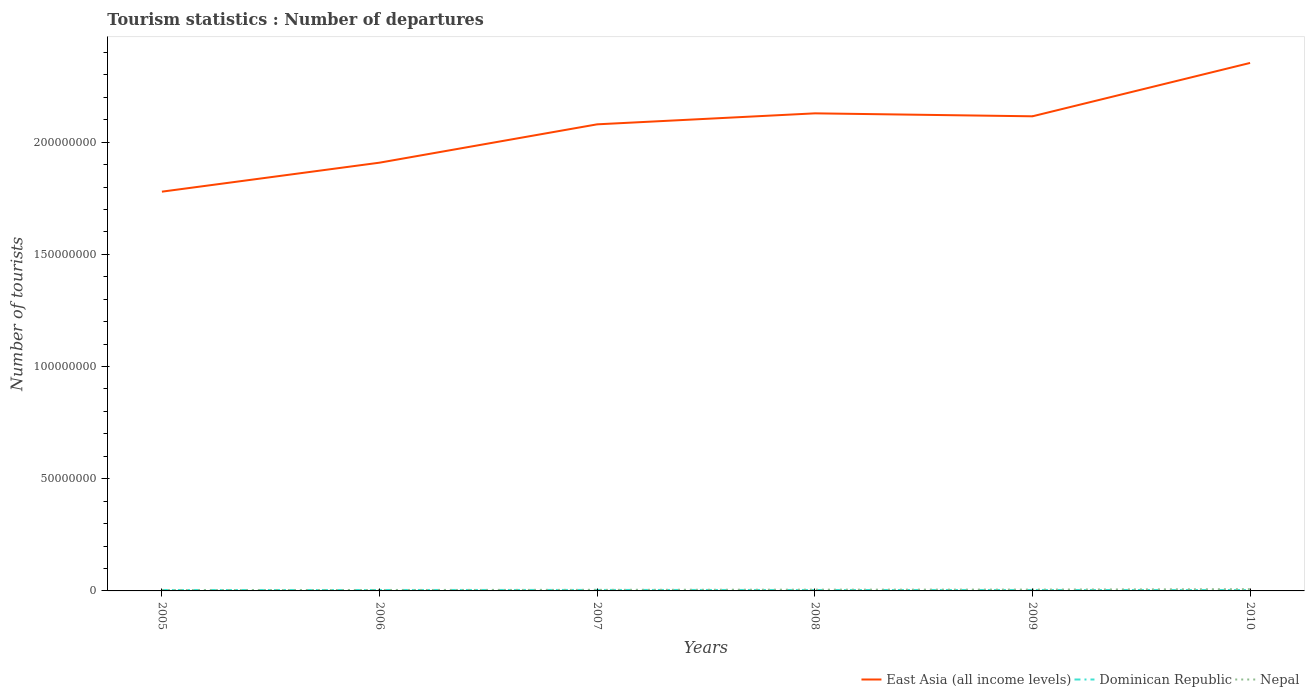Across all years, what is the maximum number of tourist departures in Nepal?
Keep it short and to the point. 3.73e+05. What is the total number of tourist departures in East Asia (all income levels) in the graph?
Keep it short and to the point. -2.38e+07. What is the difference between the highest and the second highest number of tourist departures in Dominican Republic?
Provide a short and direct response. 4.20e+04. Is the number of tourist departures in East Asia (all income levels) strictly greater than the number of tourist departures in Nepal over the years?
Provide a succinct answer. No. How many years are there in the graph?
Ensure brevity in your answer.  6. What is the difference between two consecutive major ticks on the Y-axis?
Make the answer very short. 5.00e+07. Does the graph contain any zero values?
Offer a very short reply. No. Does the graph contain grids?
Offer a very short reply. No. Where does the legend appear in the graph?
Provide a short and direct response. Bottom right. How many legend labels are there?
Your response must be concise. 3. How are the legend labels stacked?
Provide a succinct answer. Horizontal. What is the title of the graph?
Your answer should be very brief. Tourism statistics : Number of departures. Does "High income: nonOECD" appear as one of the legend labels in the graph?
Ensure brevity in your answer.  No. What is the label or title of the X-axis?
Keep it short and to the point. Years. What is the label or title of the Y-axis?
Keep it short and to the point. Number of tourists. What is the Number of tourists of East Asia (all income levels) in 2005?
Your answer should be very brief. 1.78e+08. What is the Number of tourists of Dominican Republic in 2005?
Provide a short and direct response. 4.19e+05. What is the Number of tourists in Nepal in 2005?
Your answer should be very brief. 3.73e+05. What is the Number of tourists of East Asia (all income levels) in 2006?
Make the answer very short. 1.91e+08. What is the Number of tourists in Nepal in 2006?
Provide a short and direct response. 4.15e+05. What is the Number of tourists in East Asia (all income levels) in 2007?
Give a very brief answer. 2.08e+08. What is the Number of tourists of Dominican Republic in 2007?
Ensure brevity in your answer.  4.43e+05. What is the Number of tourists of Nepal in 2007?
Provide a short and direct response. 4.69e+05. What is the Number of tourists of East Asia (all income levels) in 2008?
Offer a terse response. 2.13e+08. What is the Number of tourists in Dominican Republic in 2008?
Give a very brief answer. 4.13e+05. What is the Number of tourists of Nepal in 2008?
Your answer should be compact. 5.61e+05. What is the Number of tourists in East Asia (all income levels) in 2009?
Your response must be concise. 2.12e+08. What is the Number of tourists of Dominican Republic in 2009?
Provide a short and direct response. 4.15e+05. What is the Number of tourists in Nepal in 2009?
Provide a short and direct response. 5.89e+05. What is the Number of tourists in East Asia (all income levels) in 2010?
Provide a succinct answer. 2.35e+08. What is the Number of tourists in Dominican Republic in 2010?
Provide a short and direct response. 4.01e+05. What is the Number of tourists in Nepal in 2010?
Your answer should be very brief. 7.65e+05. Across all years, what is the maximum Number of tourists in East Asia (all income levels)?
Give a very brief answer. 2.35e+08. Across all years, what is the maximum Number of tourists in Dominican Republic?
Your response must be concise. 4.43e+05. Across all years, what is the maximum Number of tourists of Nepal?
Provide a succinct answer. 7.65e+05. Across all years, what is the minimum Number of tourists in East Asia (all income levels)?
Offer a very short reply. 1.78e+08. Across all years, what is the minimum Number of tourists in Dominican Republic?
Your response must be concise. 4.01e+05. Across all years, what is the minimum Number of tourists in Nepal?
Make the answer very short. 3.73e+05. What is the total Number of tourists of East Asia (all income levels) in the graph?
Provide a succinct answer. 1.24e+09. What is the total Number of tourists of Dominican Republic in the graph?
Give a very brief answer. 2.51e+06. What is the total Number of tourists in Nepal in the graph?
Offer a very short reply. 3.17e+06. What is the difference between the Number of tourists in East Asia (all income levels) in 2005 and that in 2006?
Give a very brief answer. -1.29e+07. What is the difference between the Number of tourists of Dominican Republic in 2005 and that in 2006?
Your answer should be compact. -1000. What is the difference between the Number of tourists in Nepal in 2005 and that in 2006?
Offer a terse response. -4.20e+04. What is the difference between the Number of tourists of East Asia (all income levels) in 2005 and that in 2007?
Your response must be concise. -3.00e+07. What is the difference between the Number of tourists in Dominican Republic in 2005 and that in 2007?
Your answer should be compact. -2.40e+04. What is the difference between the Number of tourists in Nepal in 2005 and that in 2007?
Offer a very short reply. -9.60e+04. What is the difference between the Number of tourists of East Asia (all income levels) in 2005 and that in 2008?
Offer a terse response. -3.49e+07. What is the difference between the Number of tourists of Dominican Republic in 2005 and that in 2008?
Your answer should be compact. 6000. What is the difference between the Number of tourists in Nepal in 2005 and that in 2008?
Your answer should be very brief. -1.88e+05. What is the difference between the Number of tourists of East Asia (all income levels) in 2005 and that in 2009?
Offer a terse response. -3.36e+07. What is the difference between the Number of tourists in Dominican Republic in 2005 and that in 2009?
Make the answer very short. 4000. What is the difference between the Number of tourists in Nepal in 2005 and that in 2009?
Offer a terse response. -2.16e+05. What is the difference between the Number of tourists in East Asia (all income levels) in 2005 and that in 2010?
Your answer should be compact. -5.74e+07. What is the difference between the Number of tourists in Dominican Republic in 2005 and that in 2010?
Give a very brief answer. 1.80e+04. What is the difference between the Number of tourists in Nepal in 2005 and that in 2010?
Ensure brevity in your answer.  -3.92e+05. What is the difference between the Number of tourists in East Asia (all income levels) in 2006 and that in 2007?
Offer a very short reply. -1.71e+07. What is the difference between the Number of tourists of Dominican Republic in 2006 and that in 2007?
Provide a short and direct response. -2.30e+04. What is the difference between the Number of tourists in Nepal in 2006 and that in 2007?
Provide a short and direct response. -5.40e+04. What is the difference between the Number of tourists of East Asia (all income levels) in 2006 and that in 2008?
Provide a short and direct response. -2.20e+07. What is the difference between the Number of tourists of Dominican Republic in 2006 and that in 2008?
Your answer should be compact. 7000. What is the difference between the Number of tourists of Nepal in 2006 and that in 2008?
Keep it short and to the point. -1.46e+05. What is the difference between the Number of tourists of East Asia (all income levels) in 2006 and that in 2009?
Keep it short and to the point. -2.07e+07. What is the difference between the Number of tourists in Nepal in 2006 and that in 2009?
Give a very brief answer. -1.74e+05. What is the difference between the Number of tourists in East Asia (all income levels) in 2006 and that in 2010?
Offer a very short reply. -4.45e+07. What is the difference between the Number of tourists in Dominican Republic in 2006 and that in 2010?
Give a very brief answer. 1.90e+04. What is the difference between the Number of tourists of Nepal in 2006 and that in 2010?
Offer a terse response. -3.50e+05. What is the difference between the Number of tourists in East Asia (all income levels) in 2007 and that in 2008?
Ensure brevity in your answer.  -4.89e+06. What is the difference between the Number of tourists of Dominican Republic in 2007 and that in 2008?
Make the answer very short. 3.00e+04. What is the difference between the Number of tourists in Nepal in 2007 and that in 2008?
Provide a succinct answer. -9.20e+04. What is the difference between the Number of tourists in East Asia (all income levels) in 2007 and that in 2009?
Ensure brevity in your answer.  -3.58e+06. What is the difference between the Number of tourists of Dominican Republic in 2007 and that in 2009?
Offer a very short reply. 2.80e+04. What is the difference between the Number of tourists in East Asia (all income levels) in 2007 and that in 2010?
Give a very brief answer. -2.74e+07. What is the difference between the Number of tourists in Dominican Republic in 2007 and that in 2010?
Keep it short and to the point. 4.20e+04. What is the difference between the Number of tourists in Nepal in 2007 and that in 2010?
Your answer should be very brief. -2.96e+05. What is the difference between the Number of tourists in East Asia (all income levels) in 2008 and that in 2009?
Provide a short and direct response. 1.31e+06. What is the difference between the Number of tourists of Dominican Republic in 2008 and that in 2009?
Offer a terse response. -2000. What is the difference between the Number of tourists in Nepal in 2008 and that in 2009?
Your response must be concise. -2.80e+04. What is the difference between the Number of tourists in East Asia (all income levels) in 2008 and that in 2010?
Ensure brevity in your answer.  -2.25e+07. What is the difference between the Number of tourists in Dominican Republic in 2008 and that in 2010?
Keep it short and to the point. 1.20e+04. What is the difference between the Number of tourists of Nepal in 2008 and that in 2010?
Give a very brief answer. -2.04e+05. What is the difference between the Number of tourists of East Asia (all income levels) in 2009 and that in 2010?
Your answer should be compact. -2.38e+07. What is the difference between the Number of tourists of Dominican Republic in 2009 and that in 2010?
Provide a short and direct response. 1.40e+04. What is the difference between the Number of tourists of Nepal in 2009 and that in 2010?
Offer a very short reply. -1.76e+05. What is the difference between the Number of tourists of East Asia (all income levels) in 2005 and the Number of tourists of Dominican Republic in 2006?
Ensure brevity in your answer.  1.78e+08. What is the difference between the Number of tourists of East Asia (all income levels) in 2005 and the Number of tourists of Nepal in 2006?
Offer a very short reply. 1.78e+08. What is the difference between the Number of tourists of Dominican Republic in 2005 and the Number of tourists of Nepal in 2006?
Give a very brief answer. 4000. What is the difference between the Number of tourists of East Asia (all income levels) in 2005 and the Number of tourists of Dominican Republic in 2007?
Ensure brevity in your answer.  1.77e+08. What is the difference between the Number of tourists in East Asia (all income levels) in 2005 and the Number of tourists in Nepal in 2007?
Provide a short and direct response. 1.77e+08. What is the difference between the Number of tourists in Dominican Republic in 2005 and the Number of tourists in Nepal in 2007?
Your answer should be compact. -5.00e+04. What is the difference between the Number of tourists in East Asia (all income levels) in 2005 and the Number of tourists in Dominican Republic in 2008?
Your answer should be very brief. 1.78e+08. What is the difference between the Number of tourists in East Asia (all income levels) in 2005 and the Number of tourists in Nepal in 2008?
Your response must be concise. 1.77e+08. What is the difference between the Number of tourists in Dominican Republic in 2005 and the Number of tourists in Nepal in 2008?
Your answer should be compact. -1.42e+05. What is the difference between the Number of tourists in East Asia (all income levels) in 2005 and the Number of tourists in Dominican Republic in 2009?
Ensure brevity in your answer.  1.78e+08. What is the difference between the Number of tourists of East Asia (all income levels) in 2005 and the Number of tourists of Nepal in 2009?
Give a very brief answer. 1.77e+08. What is the difference between the Number of tourists in East Asia (all income levels) in 2005 and the Number of tourists in Dominican Republic in 2010?
Make the answer very short. 1.78e+08. What is the difference between the Number of tourists in East Asia (all income levels) in 2005 and the Number of tourists in Nepal in 2010?
Your answer should be very brief. 1.77e+08. What is the difference between the Number of tourists of Dominican Republic in 2005 and the Number of tourists of Nepal in 2010?
Ensure brevity in your answer.  -3.46e+05. What is the difference between the Number of tourists in East Asia (all income levels) in 2006 and the Number of tourists in Dominican Republic in 2007?
Make the answer very short. 1.90e+08. What is the difference between the Number of tourists of East Asia (all income levels) in 2006 and the Number of tourists of Nepal in 2007?
Give a very brief answer. 1.90e+08. What is the difference between the Number of tourists in Dominican Republic in 2006 and the Number of tourists in Nepal in 2007?
Offer a terse response. -4.90e+04. What is the difference between the Number of tourists of East Asia (all income levels) in 2006 and the Number of tourists of Dominican Republic in 2008?
Offer a very short reply. 1.90e+08. What is the difference between the Number of tourists in East Asia (all income levels) in 2006 and the Number of tourists in Nepal in 2008?
Offer a terse response. 1.90e+08. What is the difference between the Number of tourists of Dominican Republic in 2006 and the Number of tourists of Nepal in 2008?
Make the answer very short. -1.41e+05. What is the difference between the Number of tourists of East Asia (all income levels) in 2006 and the Number of tourists of Dominican Republic in 2009?
Provide a short and direct response. 1.90e+08. What is the difference between the Number of tourists in East Asia (all income levels) in 2006 and the Number of tourists in Nepal in 2009?
Provide a short and direct response. 1.90e+08. What is the difference between the Number of tourists of Dominican Republic in 2006 and the Number of tourists of Nepal in 2009?
Provide a succinct answer. -1.69e+05. What is the difference between the Number of tourists in East Asia (all income levels) in 2006 and the Number of tourists in Dominican Republic in 2010?
Your response must be concise. 1.90e+08. What is the difference between the Number of tourists in East Asia (all income levels) in 2006 and the Number of tourists in Nepal in 2010?
Your answer should be compact. 1.90e+08. What is the difference between the Number of tourists of Dominican Republic in 2006 and the Number of tourists of Nepal in 2010?
Provide a succinct answer. -3.45e+05. What is the difference between the Number of tourists of East Asia (all income levels) in 2007 and the Number of tourists of Dominican Republic in 2008?
Provide a short and direct response. 2.08e+08. What is the difference between the Number of tourists in East Asia (all income levels) in 2007 and the Number of tourists in Nepal in 2008?
Provide a short and direct response. 2.07e+08. What is the difference between the Number of tourists of Dominican Republic in 2007 and the Number of tourists of Nepal in 2008?
Your answer should be compact. -1.18e+05. What is the difference between the Number of tourists in East Asia (all income levels) in 2007 and the Number of tourists in Dominican Republic in 2009?
Make the answer very short. 2.08e+08. What is the difference between the Number of tourists in East Asia (all income levels) in 2007 and the Number of tourists in Nepal in 2009?
Provide a short and direct response. 2.07e+08. What is the difference between the Number of tourists in Dominican Republic in 2007 and the Number of tourists in Nepal in 2009?
Your answer should be compact. -1.46e+05. What is the difference between the Number of tourists of East Asia (all income levels) in 2007 and the Number of tourists of Dominican Republic in 2010?
Keep it short and to the point. 2.08e+08. What is the difference between the Number of tourists in East Asia (all income levels) in 2007 and the Number of tourists in Nepal in 2010?
Provide a short and direct response. 2.07e+08. What is the difference between the Number of tourists in Dominican Republic in 2007 and the Number of tourists in Nepal in 2010?
Make the answer very short. -3.22e+05. What is the difference between the Number of tourists of East Asia (all income levels) in 2008 and the Number of tourists of Dominican Republic in 2009?
Provide a short and direct response. 2.12e+08. What is the difference between the Number of tourists in East Asia (all income levels) in 2008 and the Number of tourists in Nepal in 2009?
Your answer should be very brief. 2.12e+08. What is the difference between the Number of tourists in Dominican Republic in 2008 and the Number of tourists in Nepal in 2009?
Give a very brief answer. -1.76e+05. What is the difference between the Number of tourists in East Asia (all income levels) in 2008 and the Number of tourists in Dominican Republic in 2010?
Keep it short and to the point. 2.12e+08. What is the difference between the Number of tourists of East Asia (all income levels) in 2008 and the Number of tourists of Nepal in 2010?
Offer a terse response. 2.12e+08. What is the difference between the Number of tourists in Dominican Republic in 2008 and the Number of tourists in Nepal in 2010?
Give a very brief answer. -3.52e+05. What is the difference between the Number of tourists of East Asia (all income levels) in 2009 and the Number of tourists of Dominican Republic in 2010?
Keep it short and to the point. 2.11e+08. What is the difference between the Number of tourists of East Asia (all income levels) in 2009 and the Number of tourists of Nepal in 2010?
Provide a succinct answer. 2.11e+08. What is the difference between the Number of tourists of Dominican Republic in 2009 and the Number of tourists of Nepal in 2010?
Provide a short and direct response. -3.50e+05. What is the average Number of tourists in East Asia (all income levels) per year?
Your answer should be compact. 2.06e+08. What is the average Number of tourists of Dominican Republic per year?
Give a very brief answer. 4.18e+05. What is the average Number of tourists of Nepal per year?
Provide a short and direct response. 5.29e+05. In the year 2005, what is the difference between the Number of tourists of East Asia (all income levels) and Number of tourists of Dominican Republic?
Give a very brief answer. 1.78e+08. In the year 2005, what is the difference between the Number of tourists in East Asia (all income levels) and Number of tourists in Nepal?
Your answer should be compact. 1.78e+08. In the year 2005, what is the difference between the Number of tourists in Dominican Republic and Number of tourists in Nepal?
Your response must be concise. 4.60e+04. In the year 2006, what is the difference between the Number of tourists of East Asia (all income levels) and Number of tourists of Dominican Republic?
Make the answer very short. 1.90e+08. In the year 2006, what is the difference between the Number of tourists of East Asia (all income levels) and Number of tourists of Nepal?
Provide a succinct answer. 1.90e+08. In the year 2006, what is the difference between the Number of tourists of Dominican Republic and Number of tourists of Nepal?
Your answer should be very brief. 5000. In the year 2007, what is the difference between the Number of tourists of East Asia (all income levels) and Number of tourists of Dominican Republic?
Keep it short and to the point. 2.08e+08. In the year 2007, what is the difference between the Number of tourists in East Asia (all income levels) and Number of tourists in Nepal?
Offer a terse response. 2.07e+08. In the year 2007, what is the difference between the Number of tourists of Dominican Republic and Number of tourists of Nepal?
Ensure brevity in your answer.  -2.60e+04. In the year 2008, what is the difference between the Number of tourists in East Asia (all income levels) and Number of tourists in Dominican Republic?
Provide a succinct answer. 2.12e+08. In the year 2008, what is the difference between the Number of tourists in East Asia (all income levels) and Number of tourists in Nepal?
Ensure brevity in your answer.  2.12e+08. In the year 2008, what is the difference between the Number of tourists of Dominican Republic and Number of tourists of Nepal?
Give a very brief answer. -1.48e+05. In the year 2009, what is the difference between the Number of tourists of East Asia (all income levels) and Number of tourists of Dominican Republic?
Ensure brevity in your answer.  2.11e+08. In the year 2009, what is the difference between the Number of tourists in East Asia (all income levels) and Number of tourists in Nepal?
Keep it short and to the point. 2.11e+08. In the year 2009, what is the difference between the Number of tourists of Dominican Republic and Number of tourists of Nepal?
Keep it short and to the point. -1.74e+05. In the year 2010, what is the difference between the Number of tourists in East Asia (all income levels) and Number of tourists in Dominican Republic?
Offer a terse response. 2.35e+08. In the year 2010, what is the difference between the Number of tourists of East Asia (all income levels) and Number of tourists of Nepal?
Your answer should be compact. 2.35e+08. In the year 2010, what is the difference between the Number of tourists in Dominican Republic and Number of tourists in Nepal?
Provide a succinct answer. -3.64e+05. What is the ratio of the Number of tourists of East Asia (all income levels) in 2005 to that in 2006?
Ensure brevity in your answer.  0.93. What is the ratio of the Number of tourists of Dominican Republic in 2005 to that in 2006?
Offer a terse response. 1. What is the ratio of the Number of tourists of Nepal in 2005 to that in 2006?
Your answer should be very brief. 0.9. What is the ratio of the Number of tourists of East Asia (all income levels) in 2005 to that in 2007?
Keep it short and to the point. 0.86. What is the ratio of the Number of tourists of Dominican Republic in 2005 to that in 2007?
Give a very brief answer. 0.95. What is the ratio of the Number of tourists in Nepal in 2005 to that in 2007?
Provide a succinct answer. 0.8. What is the ratio of the Number of tourists in East Asia (all income levels) in 2005 to that in 2008?
Your answer should be compact. 0.84. What is the ratio of the Number of tourists in Dominican Republic in 2005 to that in 2008?
Give a very brief answer. 1.01. What is the ratio of the Number of tourists of Nepal in 2005 to that in 2008?
Give a very brief answer. 0.66. What is the ratio of the Number of tourists in East Asia (all income levels) in 2005 to that in 2009?
Keep it short and to the point. 0.84. What is the ratio of the Number of tourists in Dominican Republic in 2005 to that in 2009?
Keep it short and to the point. 1.01. What is the ratio of the Number of tourists of Nepal in 2005 to that in 2009?
Give a very brief answer. 0.63. What is the ratio of the Number of tourists of East Asia (all income levels) in 2005 to that in 2010?
Make the answer very short. 0.76. What is the ratio of the Number of tourists in Dominican Republic in 2005 to that in 2010?
Provide a succinct answer. 1.04. What is the ratio of the Number of tourists of Nepal in 2005 to that in 2010?
Offer a terse response. 0.49. What is the ratio of the Number of tourists of East Asia (all income levels) in 2006 to that in 2007?
Ensure brevity in your answer.  0.92. What is the ratio of the Number of tourists in Dominican Republic in 2006 to that in 2007?
Give a very brief answer. 0.95. What is the ratio of the Number of tourists in Nepal in 2006 to that in 2007?
Your response must be concise. 0.88. What is the ratio of the Number of tourists in East Asia (all income levels) in 2006 to that in 2008?
Offer a very short reply. 0.9. What is the ratio of the Number of tourists of Dominican Republic in 2006 to that in 2008?
Ensure brevity in your answer.  1.02. What is the ratio of the Number of tourists of Nepal in 2006 to that in 2008?
Offer a terse response. 0.74. What is the ratio of the Number of tourists of East Asia (all income levels) in 2006 to that in 2009?
Your answer should be compact. 0.9. What is the ratio of the Number of tourists of Dominican Republic in 2006 to that in 2009?
Provide a succinct answer. 1.01. What is the ratio of the Number of tourists in Nepal in 2006 to that in 2009?
Offer a terse response. 0.7. What is the ratio of the Number of tourists in East Asia (all income levels) in 2006 to that in 2010?
Your answer should be compact. 0.81. What is the ratio of the Number of tourists of Dominican Republic in 2006 to that in 2010?
Provide a short and direct response. 1.05. What is the ratio of the Number of tourists of Nepal in 2006 to that in 2010?
Ensure brevity in your answer.  0.54. What is the ratio of the Number of tourists in Dominican Republic in 2007 to that in 2008?
Give a very brief answer. 1.07. What is the ratio of the Number of tourists of Nepal in 2007 to that in 2008?
Make the answer very short. 0.84. What is the ratio of the Number of tourists in East Asia (all income levels) in 2007 to that in 2009?
Your answer should be very brief. 0.98. What is the ratio of the Number of tourists of Dominican Republic in 2007 to that in 2009?
Provide a short and direct response. 1.07. What is the ratio of the Number of tourists of Nepal in 2007 to that in 2009?
Give a very brief answer. 0.8. What is the ratio of the Number of tourists in East Asia (all income levels) in 2007 to that in 2010?
Offer a very short reply. 0.88. What is the ratio of the Number of tourists of Dominican Republic in 2007 to that in 2010?
Your answer should be very brief. 1.1. What is the ratio of the Number of tourists in Nepal in 2007 to that in 2010?
Offer a terse response. 0.61. What is the ratio of the Number of tourists in Nepal in 2008 to that in 2009?
Ensure brevity in your answer.  0.95. What is the ratio of the Number of tourists in East Asia (all income levels) in 2008 to that in 2010?
Make the answer very short. 0.9. What is the ratio of the Number of tourists of Dominican Republic in 2008 to that in 2010?
Offer a terse response. 1.03. What is the ratio of the Number of tourists in Nepal in 2008 to that in 2010?
Your response must be concise. 0.73. What is the ratio of the Number of tourists of East Asia (all income levels) in 2009 to that in 2010?
Give a very brief answer. 0.9. What is the ratio of the Number of tourists in Dominican Republic in 2009 to that in 2010?
Your answer should be compact. 1.03. What is the ratio of the Number of tourists of Nepal in 2009 to that in 2010?
Make the answer very short. 0.77. What is the difference between the highest and the second highest Number of tourists of East Asia (all income levels)?
Offer a very short reply. 2.25e+07. What is the difference between the highest and the second highest Number of tourists in Dominican Republic?
Provide a succinct answer. 2.30e+04. What is the difference between the highest and the second highest Number of tourists of Nepal?
Give a very brief answer. 1.76e+05. What is the difference between the highest and the lowest Number of tourists of East Asia (all income levels)?
Your response must be concise. 5.74e+07. What is the difference between the highest and the lowest Number of tourists of Dominican Republic?
Provide a short and direct response. 4.20e+04. What is the difference between the highest and the lowest Number of tourists in Nepal?
Your response must be concise. 3.92e+05. 